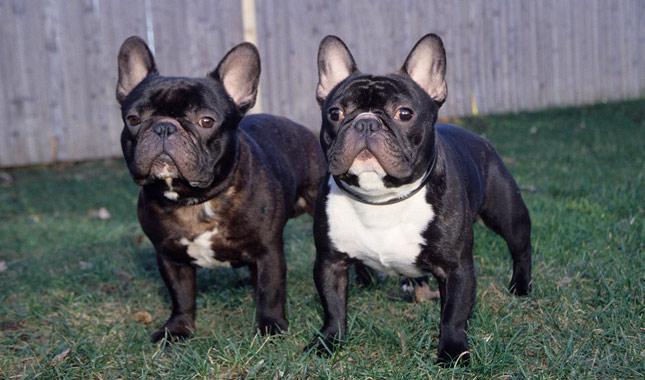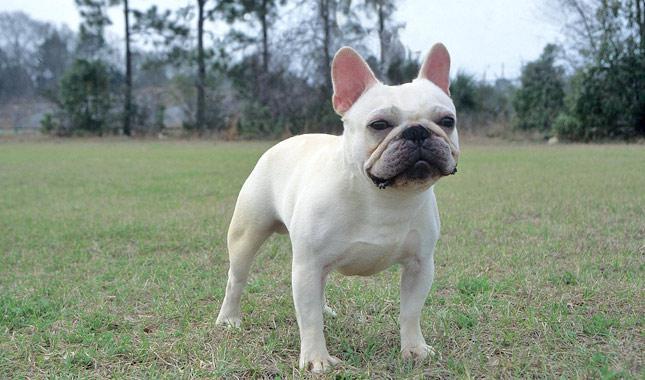The first image is the image on the left, the second image is the image on the right. Evaluate the accuracy of this statement regarding the images: "There are three dogs". Is it true? Answer yes or no. Yes. 